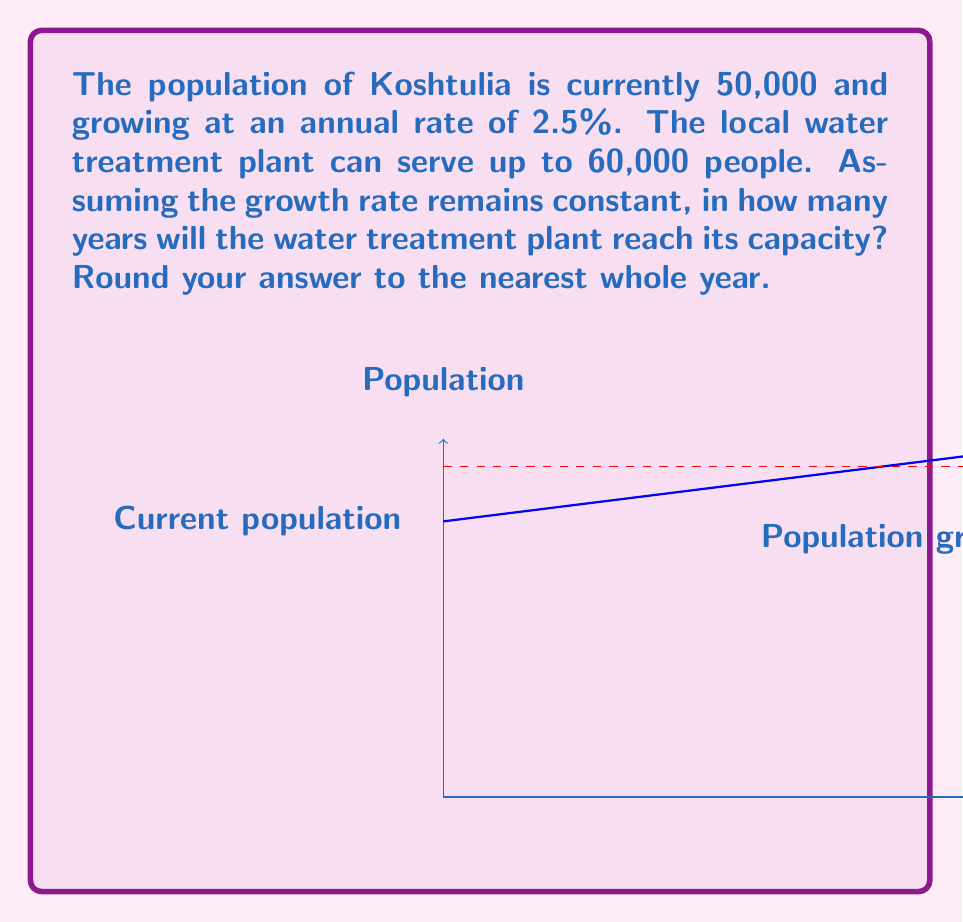Can you answer this question? Let's approach this step-by-step:

1) We can model population growth using the exponential growth formula:
   $$P(t) = P_0 \cdot e^{rt}$$
   where $P(t)$ is the population at time $t$, $P_0$ is the initial population, $r$ is the growth rate, and $t$ is time in years.

2) We have:
   $P_0 = 50,000$
   $r = 0.025$ (2.5% expressed as a decimal)
   We need to find $t$ when $P(t) = 60,000$

3) Substituting into our equation:
   $$60,000 = 50,000 \cdot e^{0.025t}$$

4) Dividing both sides by 50,000:
   $$1.2 = e^{0.025t}$$

5) Taking the natural log of both sides:
   $$\ln(1.2) = 0.025t$$

6) Solving for $t$:
   $$t = \frac{\ln(1.2)}{0.025} \approx 7.3$$

7) Rounding to the nearest whole year:
   $t = 7$ years

Therefore, it will take approximately 7 years for the water treatment plant to reach its capacity.
Answer: 7 years 